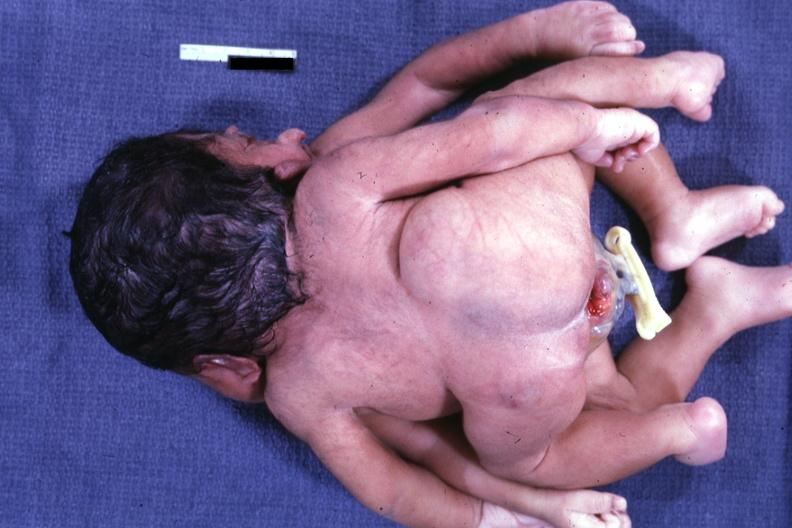what is present?
Answer the question using a single word or phrase. Cephalothoracopagus janiceps 